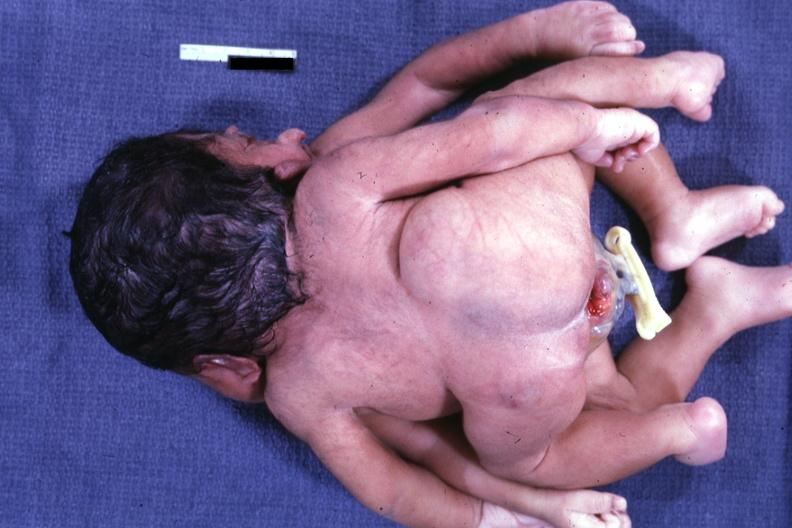what is present?
Answer the question using a single word or phrase. Cephalothoracopagus janiceps 